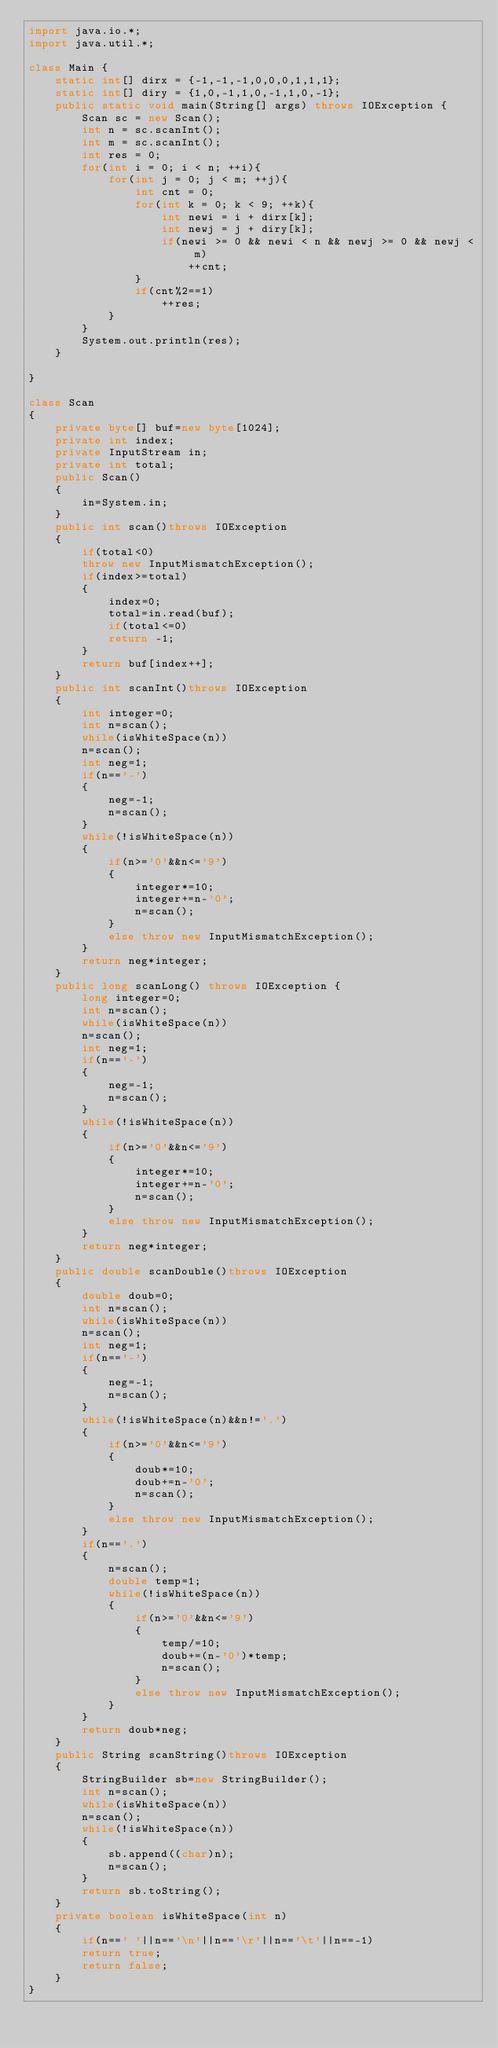<code> <loc_0><loc_0><loc_500><loc_500><_Java_>import java.io.*;
import java.util.*;

class Main {
    static int[] dirx = {-1,-1,-1,0,0,0,1,1,1};
    static int[] diry = {1,0,-1,1,0,-1,1,0,-1};
    public static void main(String[] args) throws IOException {
        Scan sc = new Scan();
        int n = sc.scanInt();
        int m = sc.scanInt();
        int res = 0;
        for(int i = 0; i < n; ++i){
            for(int j = 0; j < m; ++j){
                int cnt = 0;
                for(int k = 0; k < 9; ++k){
                    int newi = i + dirx[k];
                    int newj = j + diry[k];
                    if(newi >= 0 && newi < n && newj >= 0 && newj < m)
                        ++cnt;
                }
                if(cnt%2==1)
                    ++res;
            }
        }
        System.out.println(res);
    }
    
}

class Scan
{
    private byte[] buf=new byte[1024];
    private int index;
    private InputStream in;
    private int total;
    public Scan()
    {
        in=System.in;
    }
    public int scan()throws IOException
    {
        if(total<0)
        throw new InputMismatchException();
        if(index>=total)
        {
            index=0;
            total=in.read(buf);
            if(total<=0)
            return -1;
        }
        return buf[index++];
    }
    public int scanInt()throws IOException
    {
        int integer=0;
        int n=scan();
        while(isWhiteSpace(n))
        n=scan();
        int neg=1;
        if(n=='-')
        {
            neg=-1;
            n=scan();
        }
        while(!isWhiteSpace(n))
        {
            if(n>='0'&&n<='9')
            {
                integer*=10;
                integer+=n-'0';
                n=scan();
            }
            else throw new InputMismatchException();
        }
        return neg*integer;
    }
    public long scanLong() throws IOException {
        long integer=0;
        int n=scan();
        while(isWhiteSpace(n))
        n=scan();
        int neg=1;
        if(n=='-')
        {
            neg=-1;
            n=scan();
        }
        while(!isWhiteSpace(n))
        {
            if(n>='0'&&n<='9')
            {
                integer*=10;
                integer+=n-'0';
                n=scan();
            }
            else throw new InputMismatchException();
        }
        return neg*integer;
    }
    public double scanDouble()throws IOException
    {
        double doub=0;
        int n=scan();
        while(isWhiteSpace(n))
        n=scan();
        int neg=1;
        if(n=='-')
        {
            neg=-1;
            n=scan();
        }
        while(!isWhiteSpace(n)&&n!='.')
        {
            if(n>='0'&&n<='9')
            {
                doub*=10;
                doub+=n-'0';
                n=scan();
            }
            else throw new InputMismatchException();
        }
        if(n=='.')
        {
            n=scan();
            double temp=1;
            while(!isWhiteSpace(n))
            {
                if(n>='0'&&n<='9')
                {
                    temp/=10;
                    doub+=(n-'0')*temp;
                    n=scan();
                }
                else throw new InputMismatchException();
            }
        }
        return doub*neg;
    }
    public String scanString()throws IOException
    {
        StringBuilder sb=new StringBuilder();
        int n=scan();
        while(isWhiteSpace(n))
        n=scan();
        while(!isWhiteSpace(n))
        {
            sb.append((char)n);
            n=scan();
        }
        return sb.toString();
    }
    private boolean isWhiteSpace(int n)
    {
        if(n==' '||n=='\n'||n=='\r'||n=='\t'||n==-1)
        return true;
        return false;
    }
}
</code> 